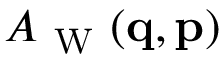Convert formula to latex. <formula><loc_0><loc_0><loc_500><loc_500>A _ { W } ( { q } , { p } )</formula> 